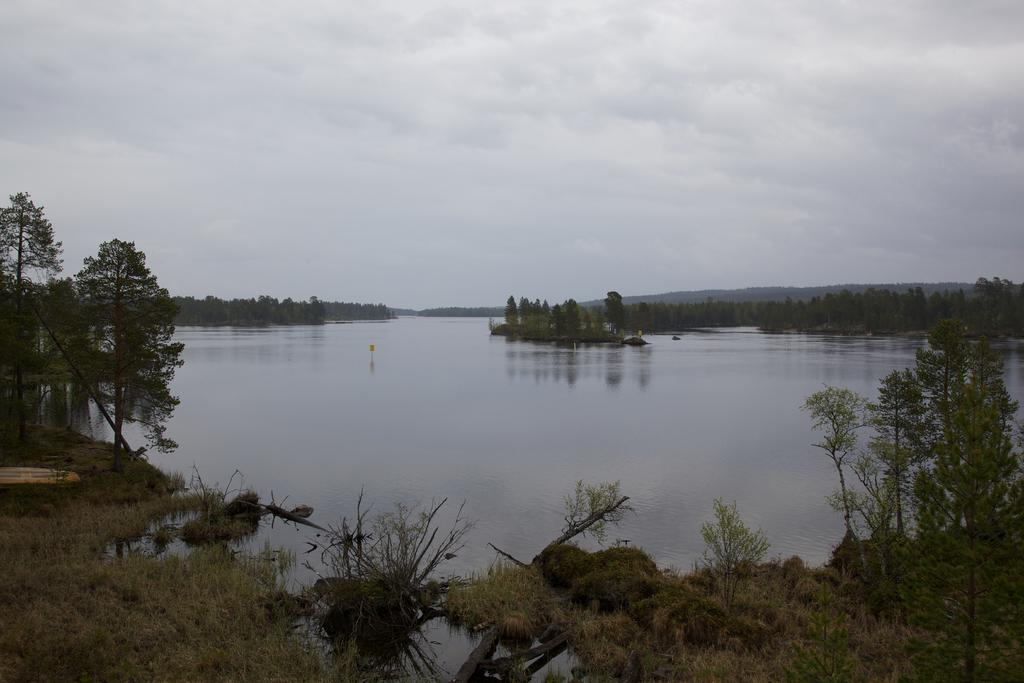What type of vegetation can be seen in the image? There are plants and trees in the image. What type of ground surface is visible in the image? There is grass in the image. What is the water feature in the image? There is water visible in the image. What is the pole used for in the image? The purpose of the pole is not specified in the image. What is the object in the image? The object in the image is not described in detail. What is the weather like in the image? The sky is visible in the background of the image, and it appears to be cloudy. How many cars are parked on the grass in the image? There are no cars visible in the image; it features plants, trees, grass, water, a pole, and an object. What color is the sofa in the image? There is no sofa present in the image. 